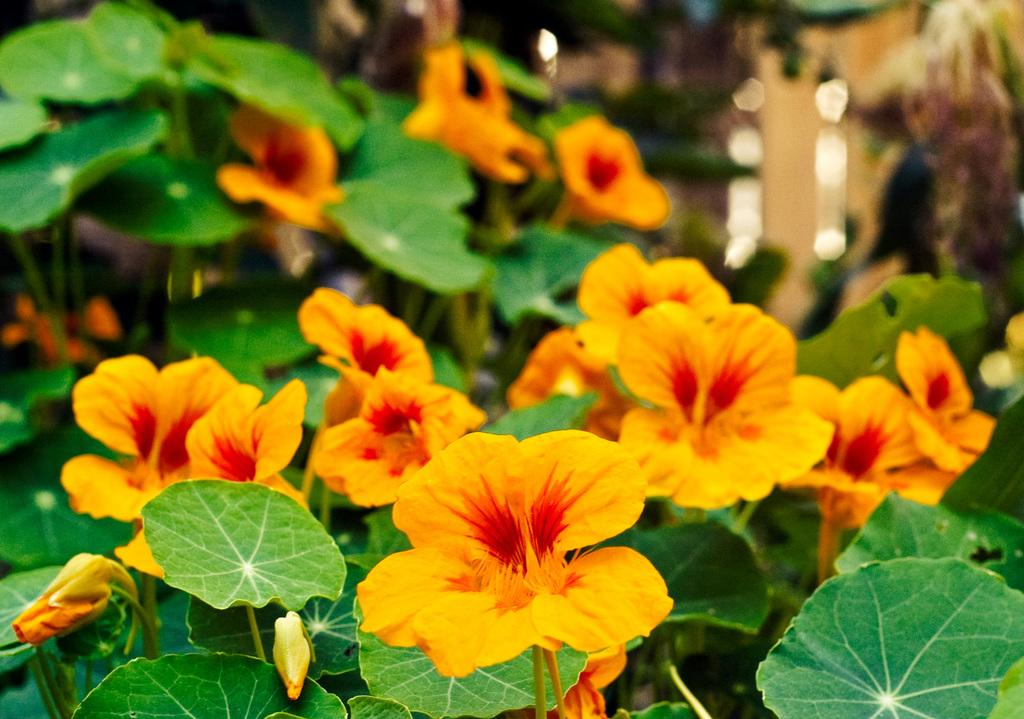What type of living organisms can be seen in the image? There are flowers and plants visible in the image. What stage of growth are some of the flowers in? There are buds in the image, which indicates that some flowers are in the early stages of growth. How would you describe the background of the image? The background of the image is blurred. What type of hydrant can be seen in the image? There is no hydrant present in the image. What type of teeth can be seen on the flowers in the image? Flowers do not have teeth, so there are no teeth visible on the flowers in the image. 